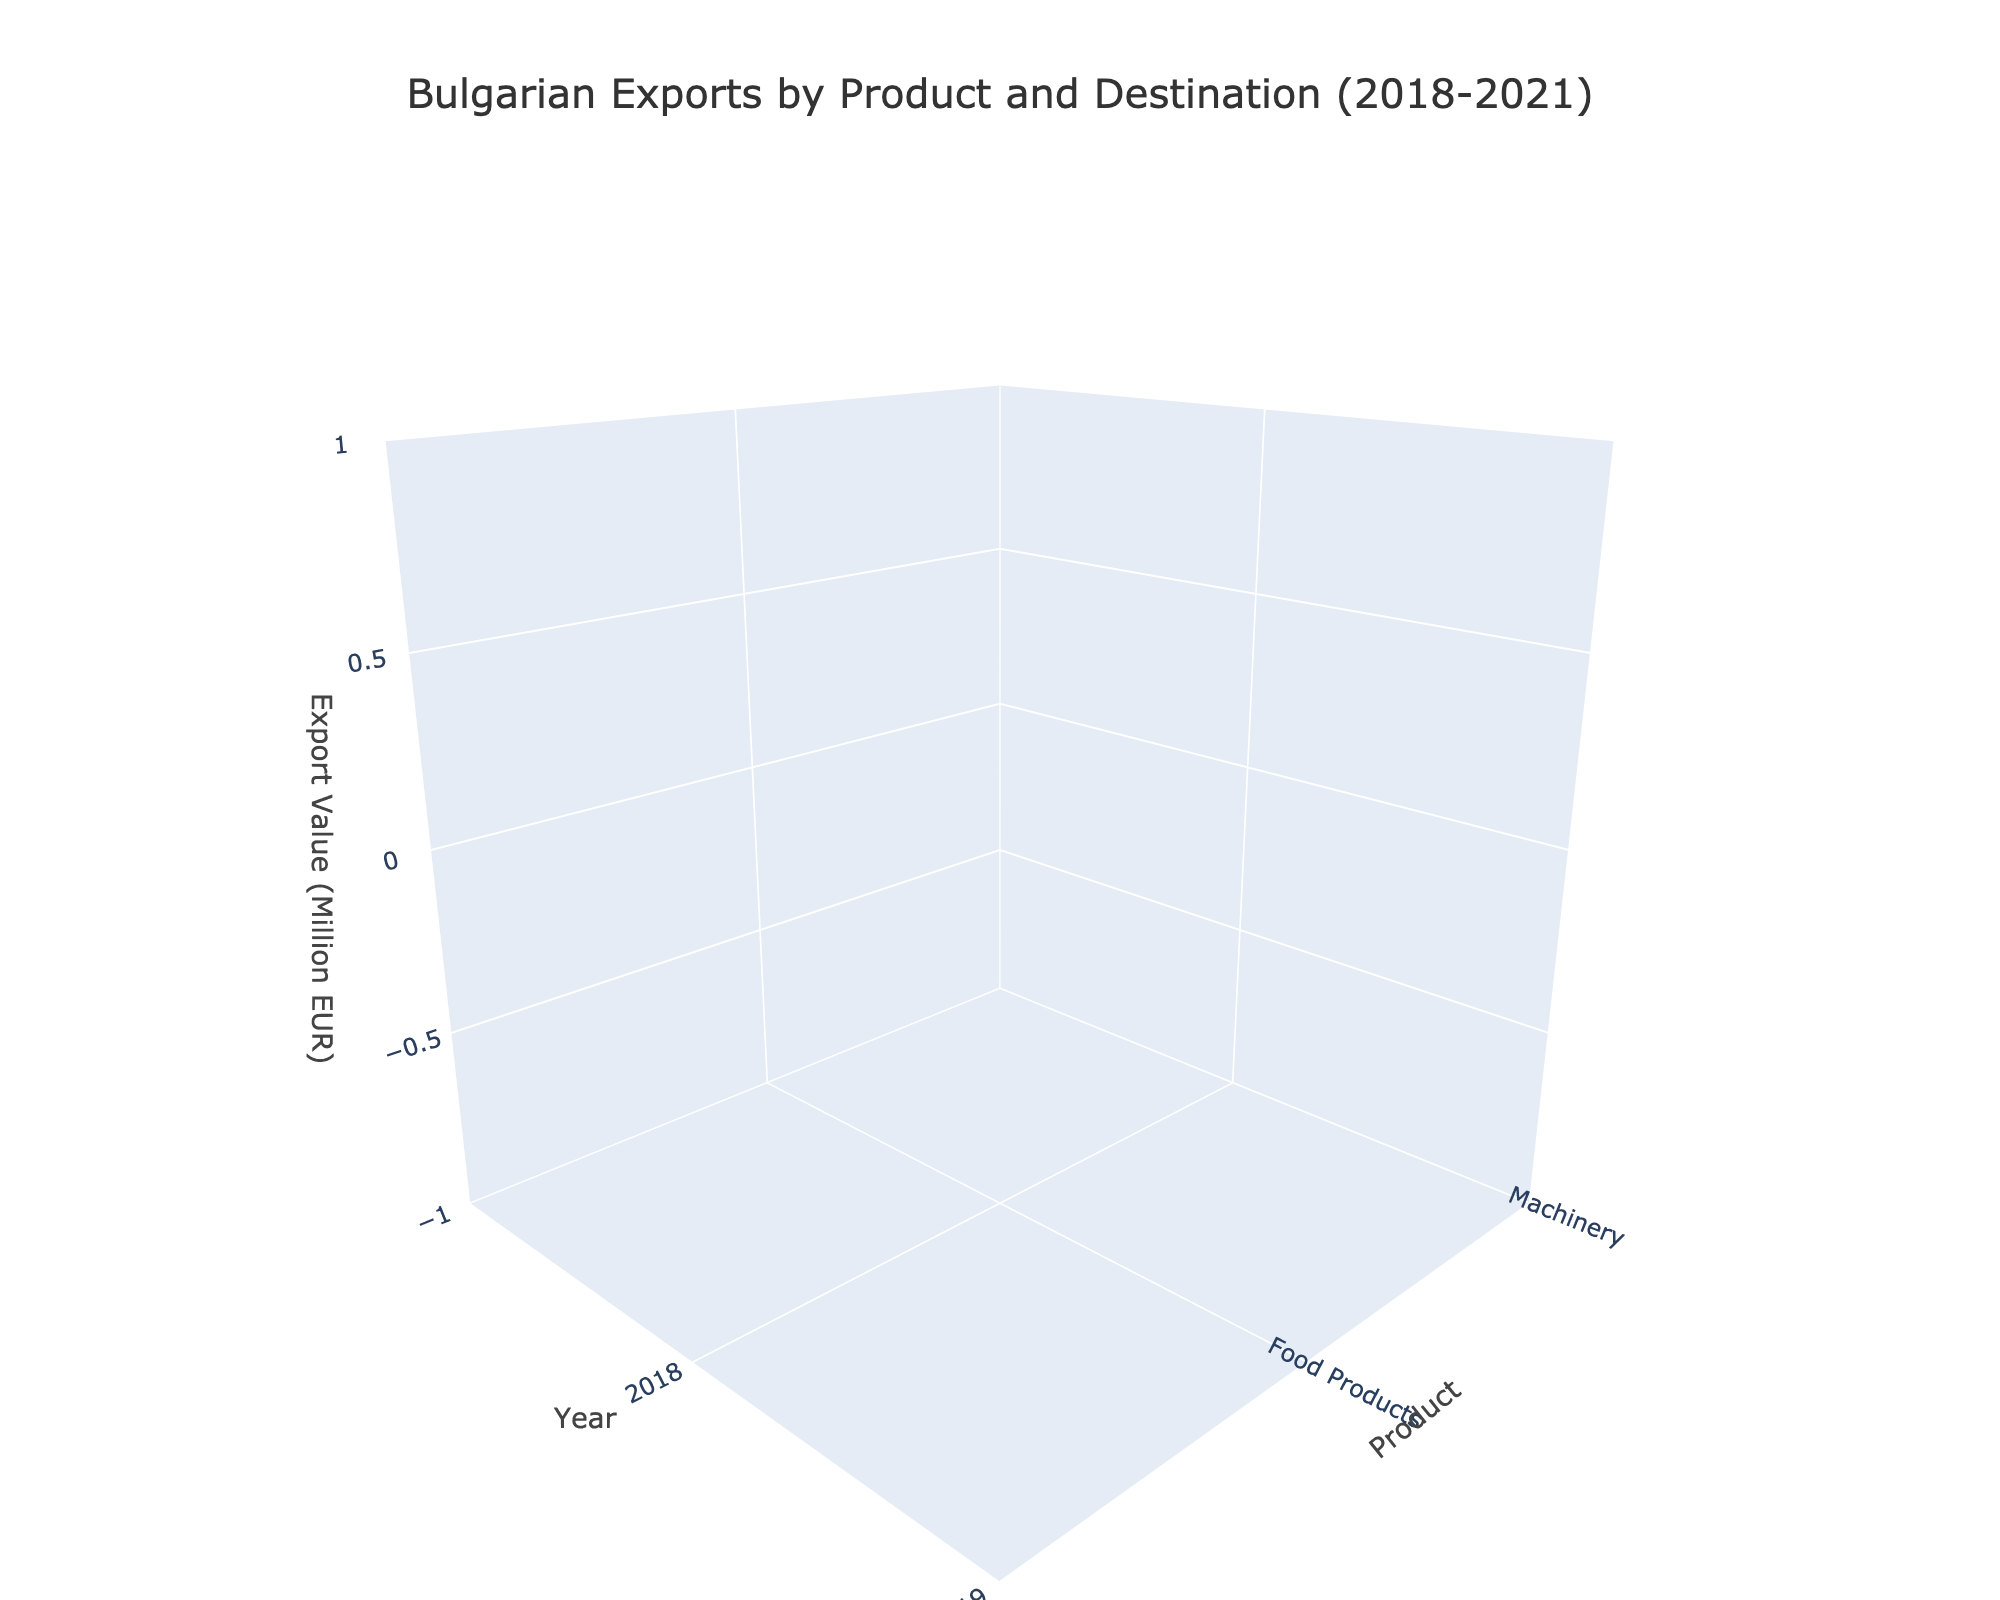What's the title of the plot? The title of the plot is displayed at the top of the figure. It provides a summary to viewers about what the figure represents.
Answer: Bulgarian Exports by Product and Destination (2018-2021) Which year had the highest export value for machinery to Germany? By looking at the 3D surface plot specific to the destination "Germany" and the product "Machinery," we can compare the height of the surface over the years. The highest point in that part of the surface corresponds to the highest export value.
Answer: 2021 What product saw the most consistent export growth to Italy from 2018 to 2021? Assess the surfaces over "Italy" and compare the trends for each product. "Most consistent growth" implies looking for a steady upward trend across the years.
Answer: Food Products Compare the export values of textiles to Romania in 2019 and 2020. Which year had higher exports? Locate the specific part of the 3D surface plot corresponding to "Textiles" destined for "Romania" and then compare the surface heights for the years 2019 and 2020.
Answer: 2019 How does the export value trend for machinery to Germany compare against machinery to Italy from 2018 to 2021? Examine the surfaces for "Machinery" for both "Germany" and "Italy." Note the changes in height (representing export values) over the years to identify any similarities or differences in the trends.
Answer: Germany's trend is slightly more variable but generally increasing; Italy's trend is flatter What's the average export value of food products to Germany from 2018 to 2021? Calculate the average by summing the export values for food products to Germany for all the provided years and dividing by the number of years. (480 + 510 + 540 + 570) / 4
Answer: 525 Million EUR Was there any year where the export value of textiles to Italy dropped compared to the previous year? Analyze the vertical changes in heights for the segment representing "Textiles" to "Italy" across all the years. Identify if there is any drop between consecutive years.
Answer: No Which product had the highest export value to Germany in 2018? Locate the surface part corresponding to the year 2018 for destination "Germany," and compare the heights for "Machinery," "Textiles," and "Food Products." The highest point among these represents the highest export value.
Answer: Machinery How did the export values of food products to Romania in 2021 compare to those in 2018? Compare the surface heights for "Food Products" to "Romania" for the years 2018 and 2021. Identify which height is higher to determine the change.
Answer: 2021 had higher exports Which product had the least variation in export value to Romania over the years 2018-2021? For each product, observe the part of the surface corresponding to "Romania." The product with the least change in height over the years indicates the least variation in export values.
Answer: Food Products 